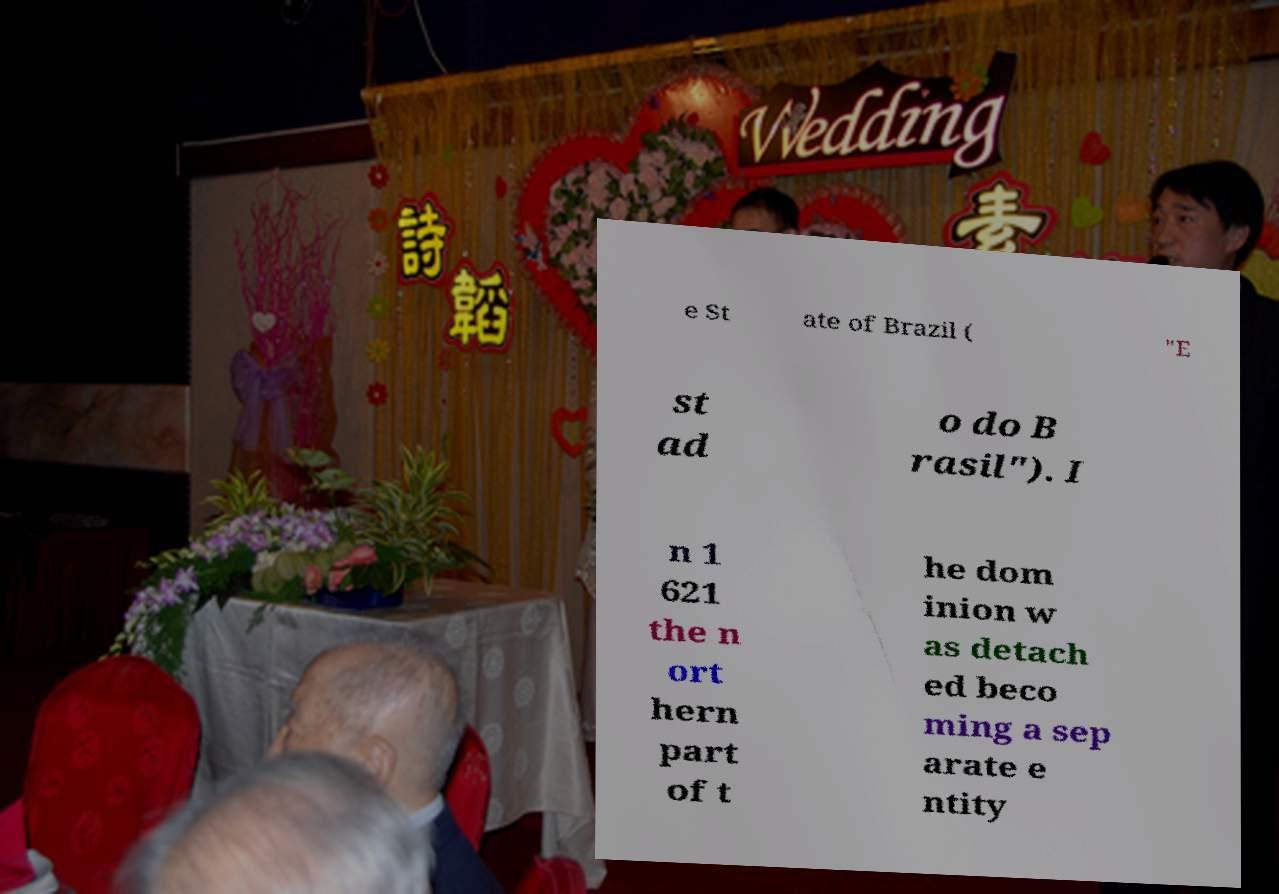There's text embedded in this image that I need extracted. Can you transcribe it verbatim? e St ate of Brazil ( "E st ad o do B rasil"). I n 1 621 the n ort hern part of t he dom inion w as detach ed beco ming a sep arate e ntity 